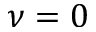Convert formula to latex. <formula><loc_0><loc_0><loc_500><loc_500>\nu = 0</formula> 